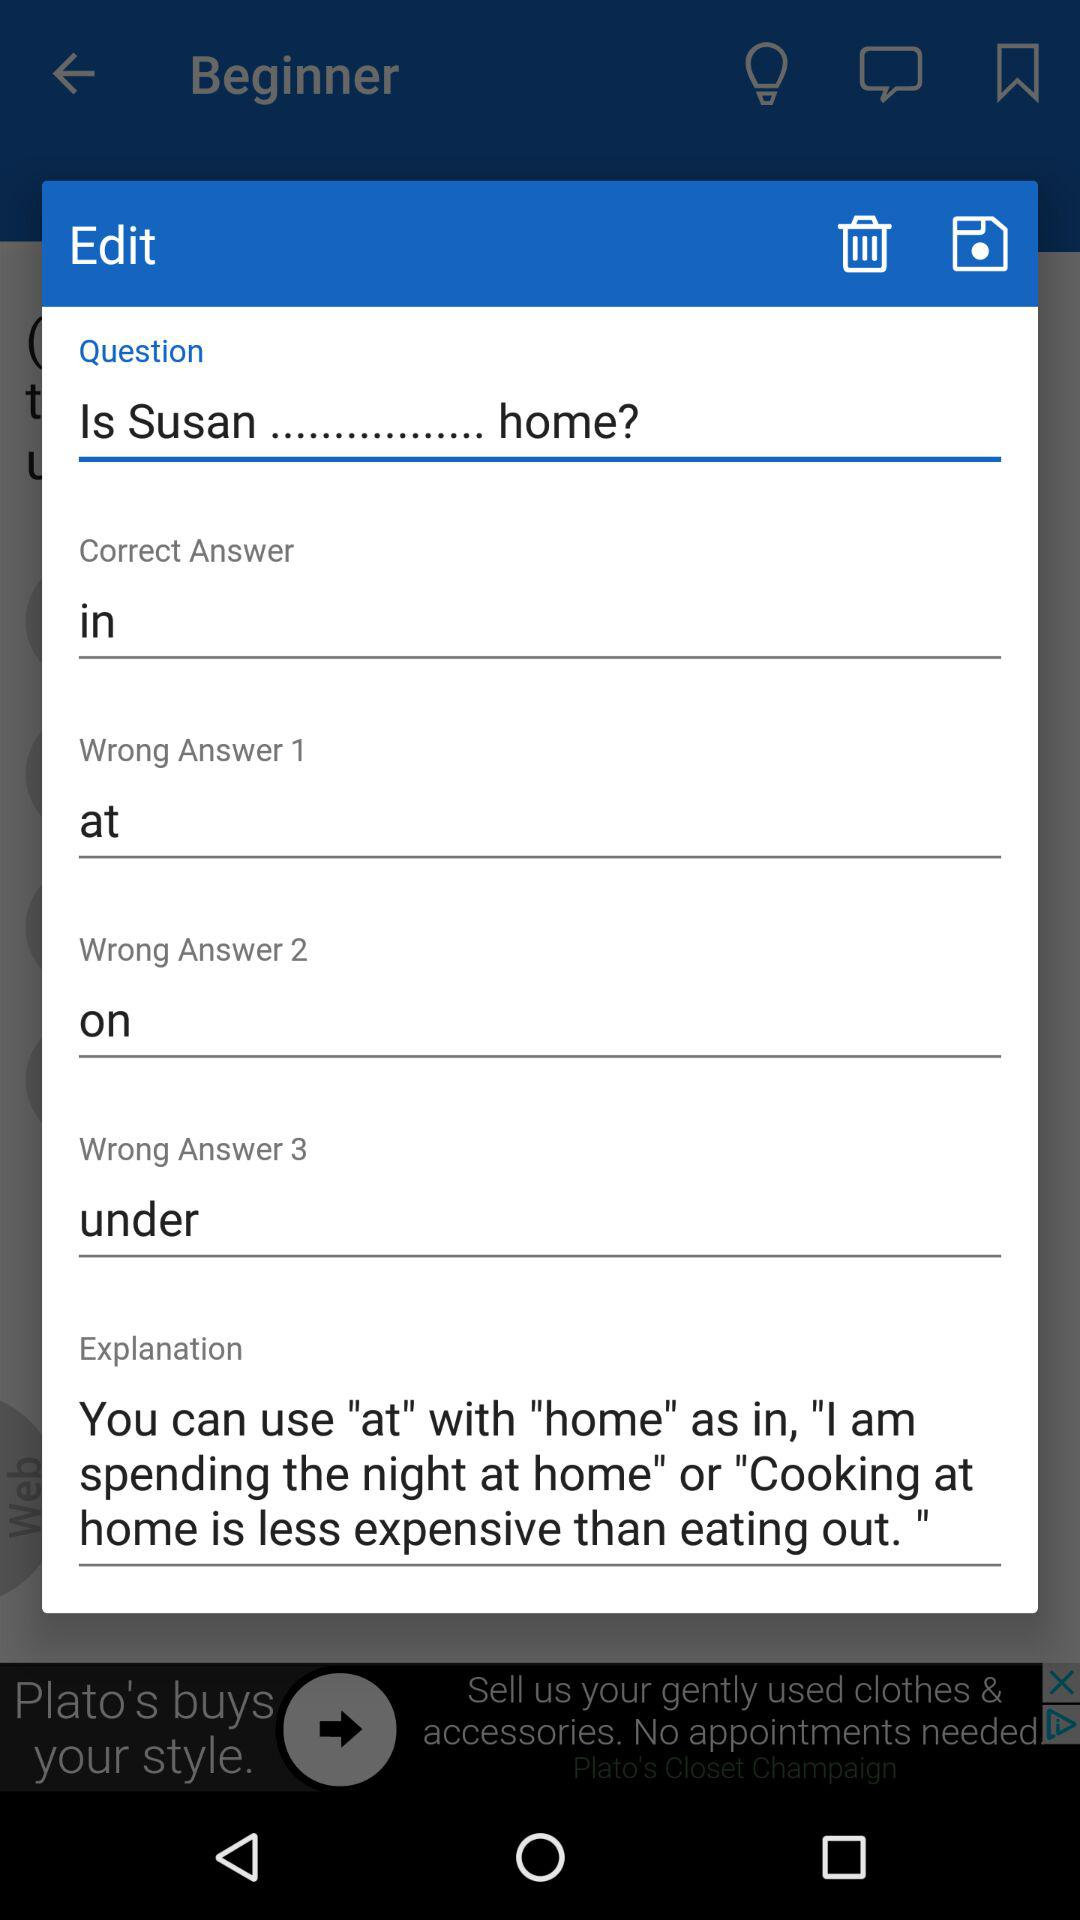What's the correct answer to the question? The correct answer is "in". 